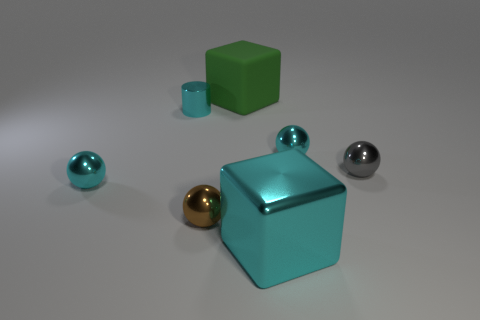How many objects in total are there in the image? There are five objects in the image, including two cubes, two spheres, and a cylinder. 